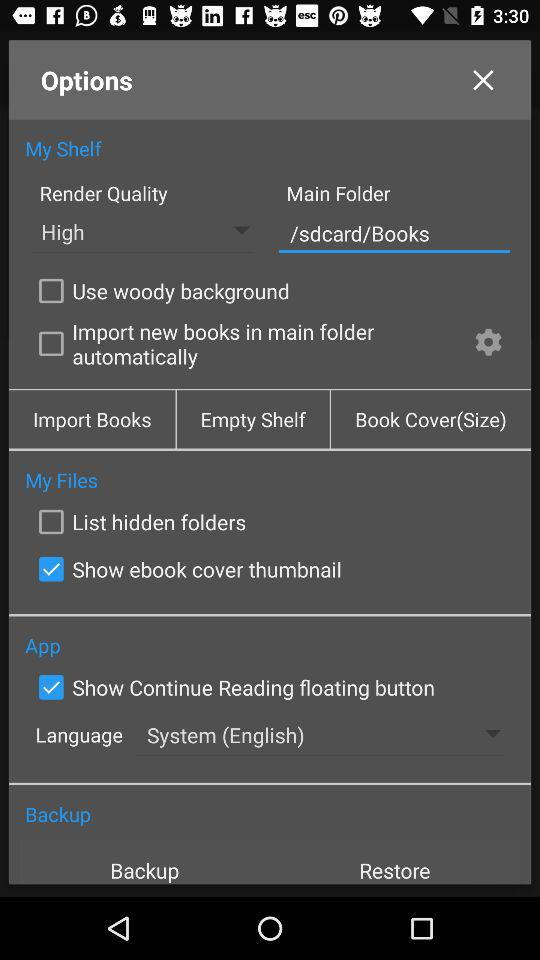What is the status of the "Use woody background"? The status is "off". 